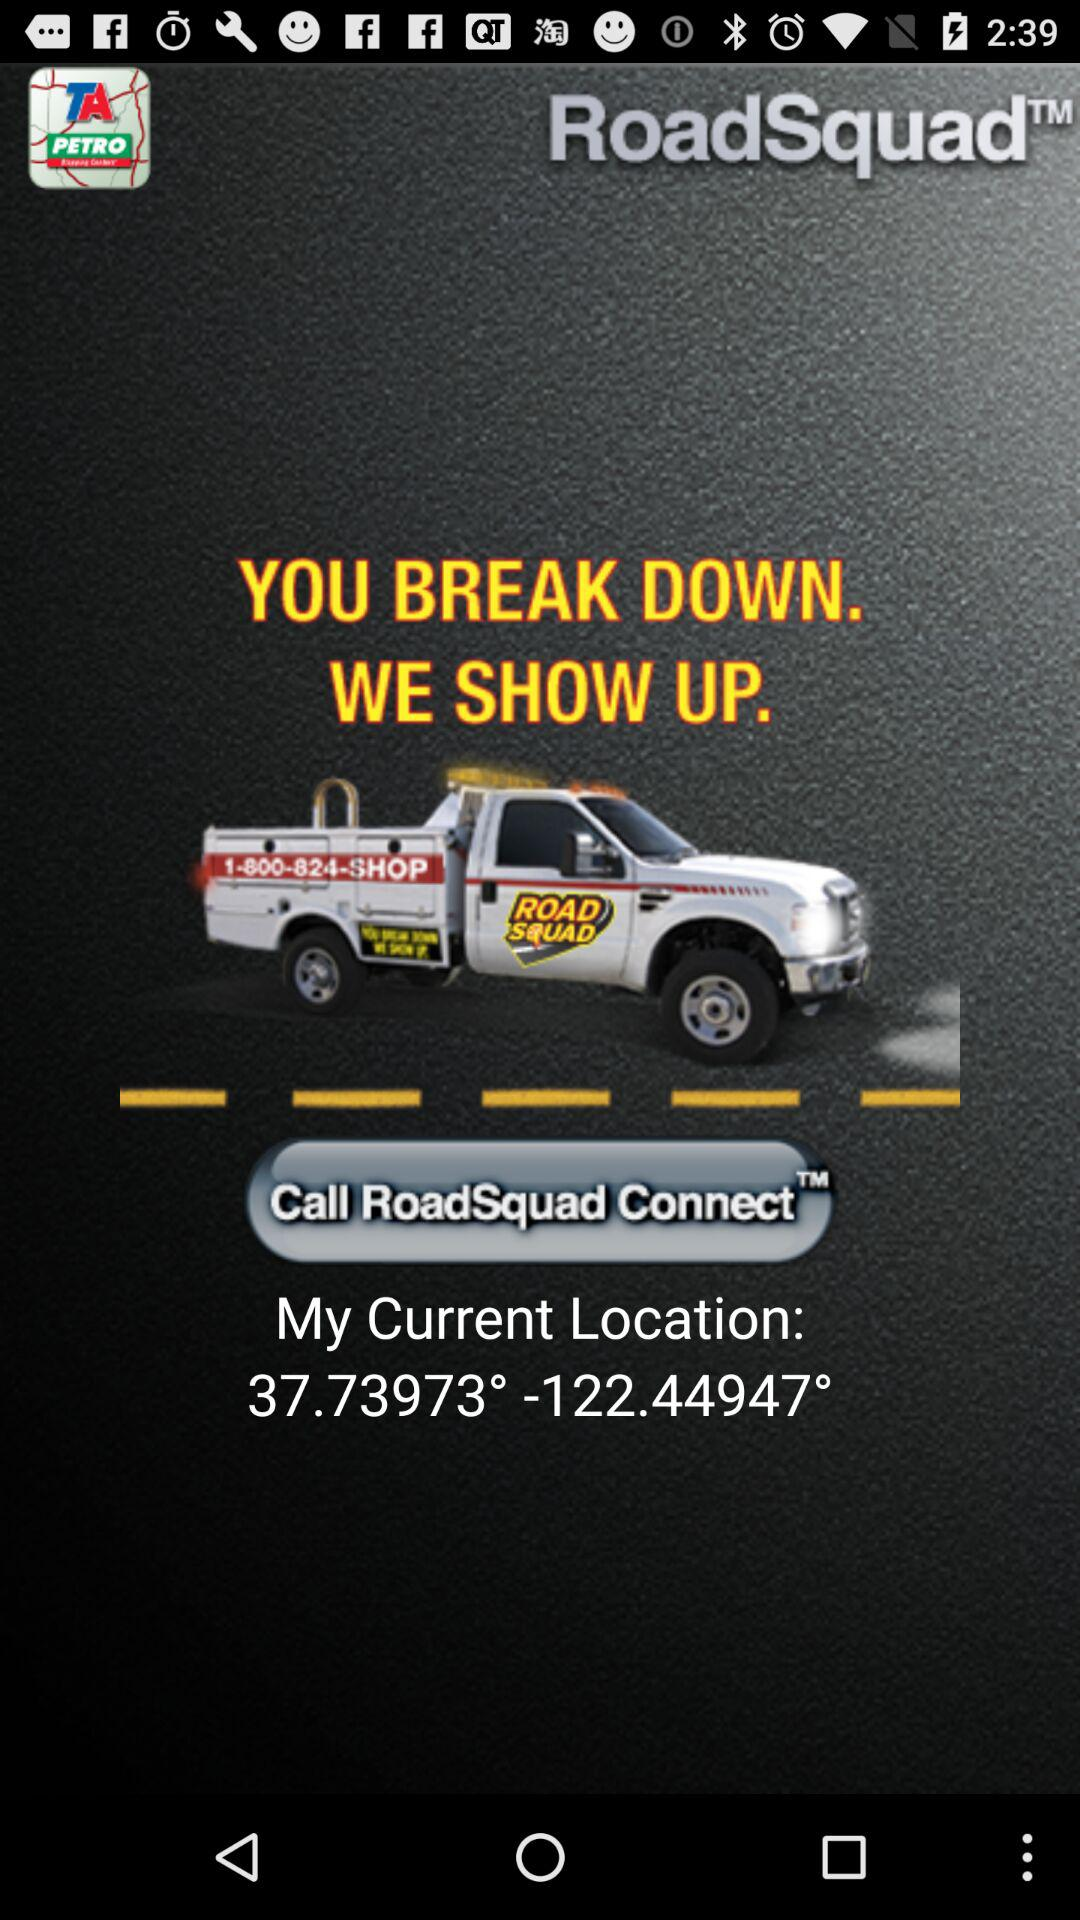What is the current Location? The current location is 37.73973°, -122.44947°. 